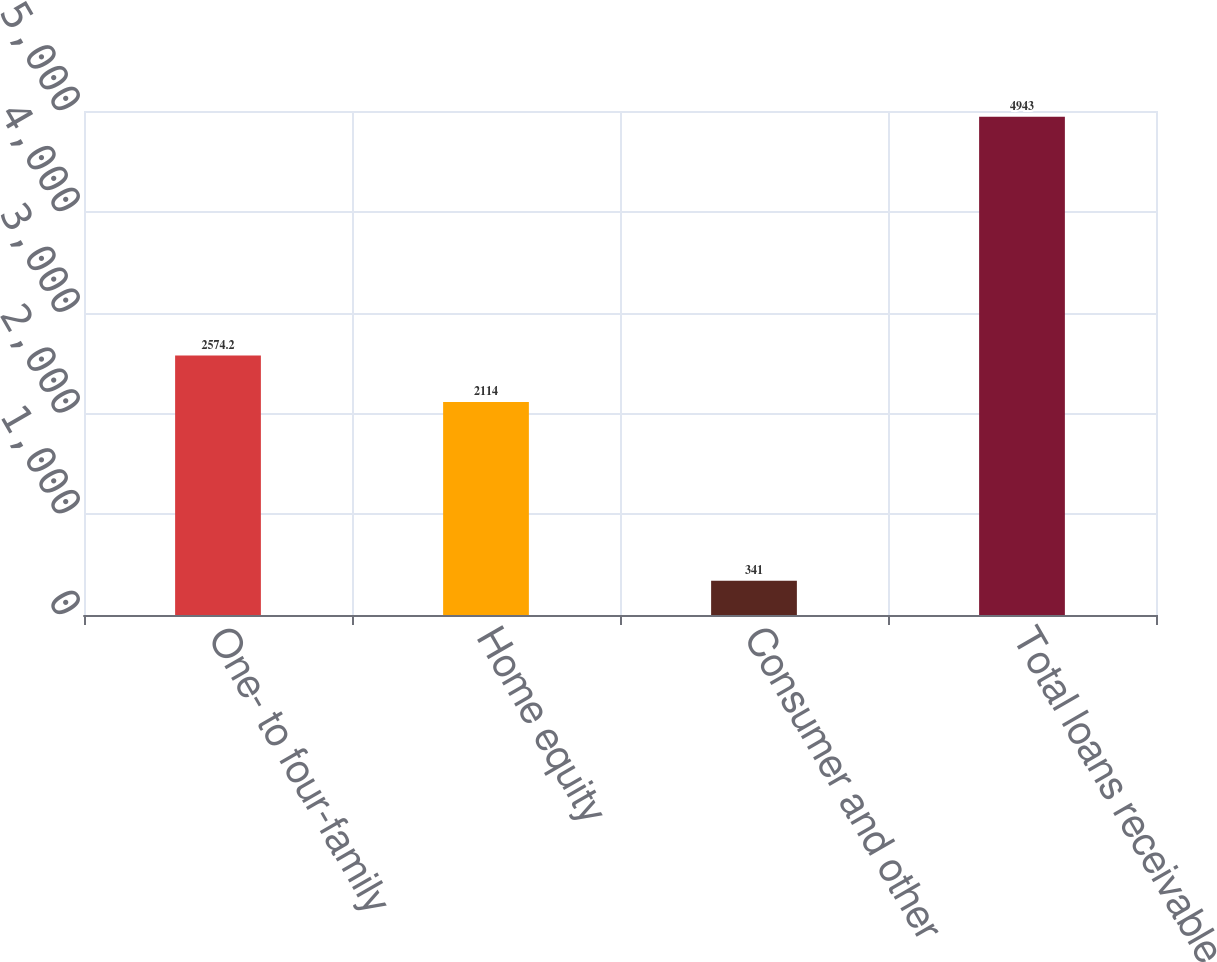<chart> <loc_0><loc_0><loc_500><loc_500><bar_chart><fcel>One- to four-family<fcel>Home equity<fcel>Consumer and other<fcel>Total loans receivable<nl><fcel>2574.2<fcel>2114<fcel>341<fcel>4943<nl></chart> 